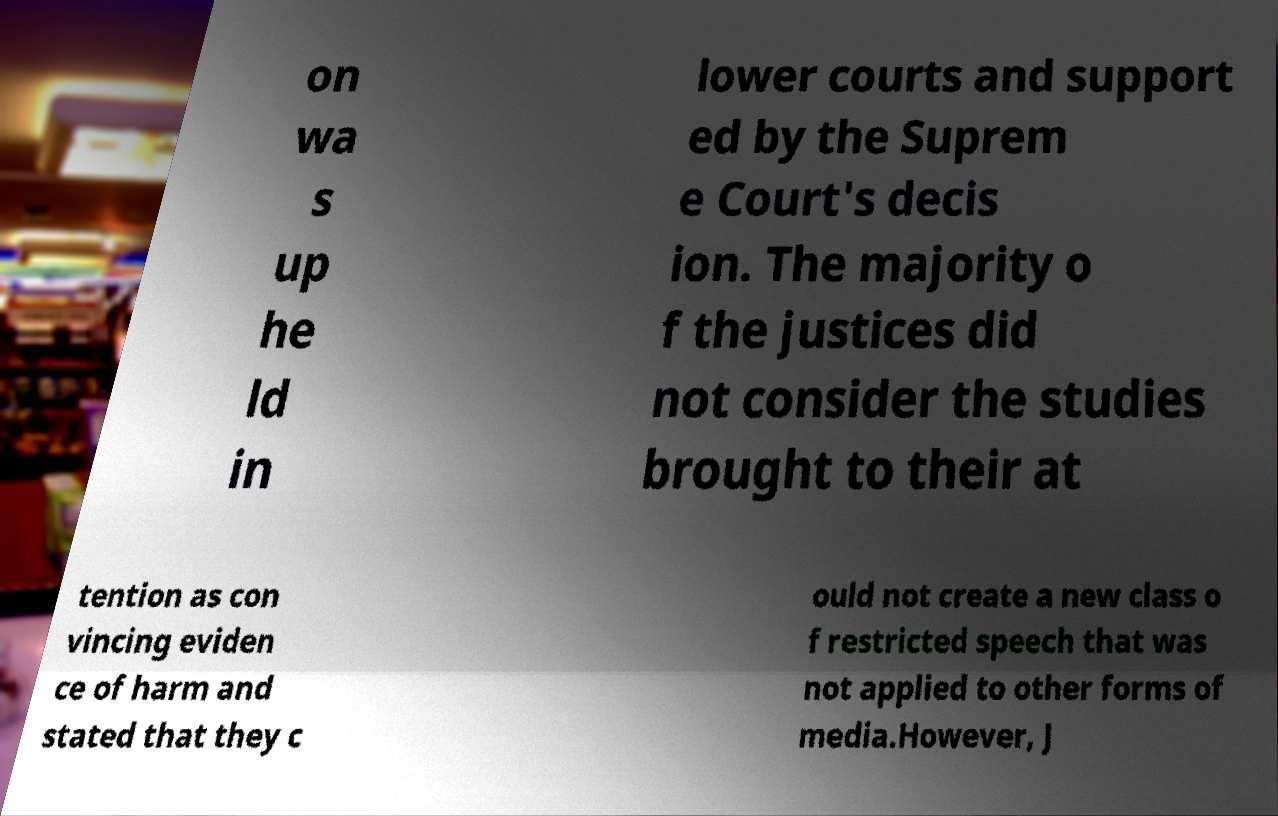Could you extract and type out the text from this image? on wa s up he ld in lower courts and support ed by the Suprem e Court's decis ion. The majority o f the justices did not consider the studies brought to their at tention as con vincing eviden ce of harm and stated that they c ould not create a new class o f restricted speech that was not applied to other forms of media.However, J 